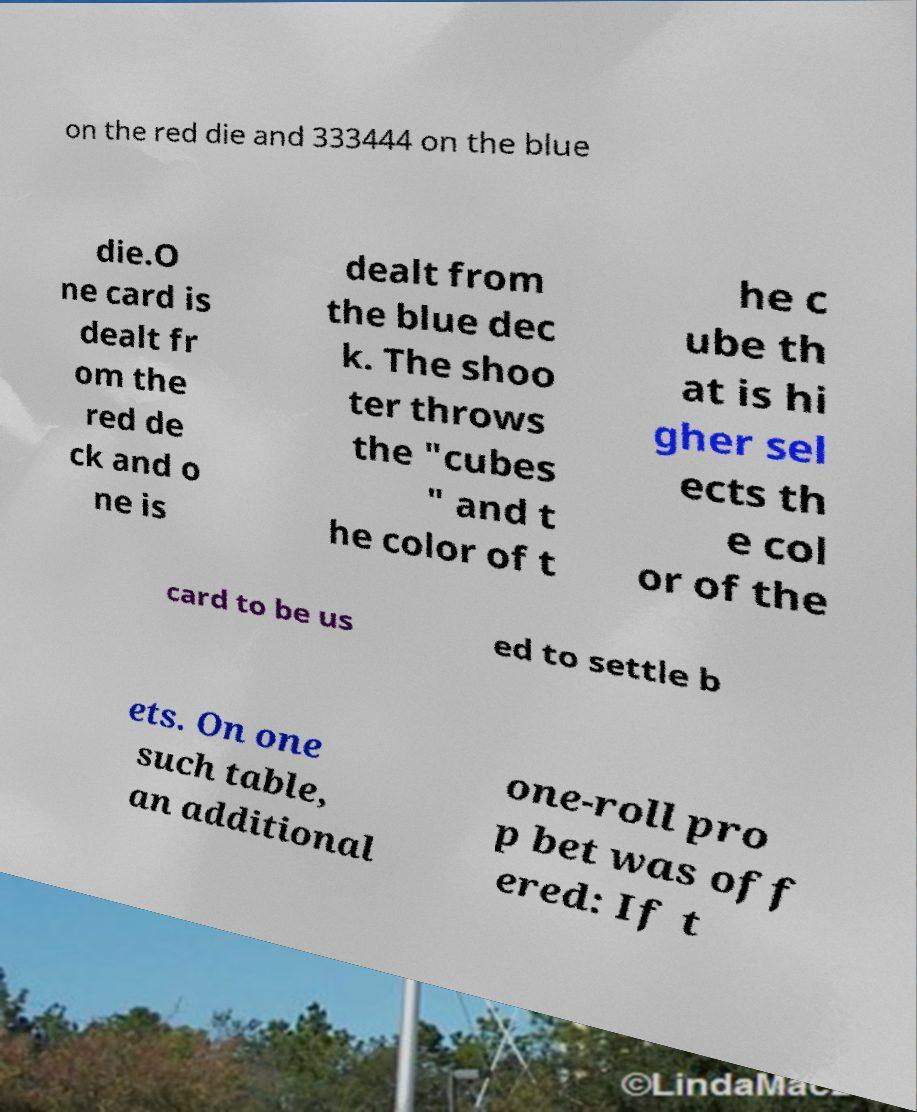For documentation purposes, I need the text within this image transcribed. Could you provide that? on the red die and 333444 on the blue die.O ne card is dealt fr om the red de ck and o ne is dealt from the blue dec k. The shoo ter throws the "cubes " and t he color of t he c ube th at is hi gher sel ects th e col or of the card to be us ed to settle b ets. On one such table, an additional one-roll pro p bet was off ered: If t 